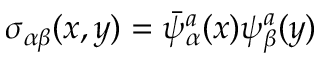<formula> <loc_0><loc_0><loc_500><loc_500>\sigma _ { \alpha \beta } ( x , y ) = \bar { \psi } _ { \alpha } ^ { a } ( x ) \psi _ { \beta } ^ { a } ( y )</formula> 